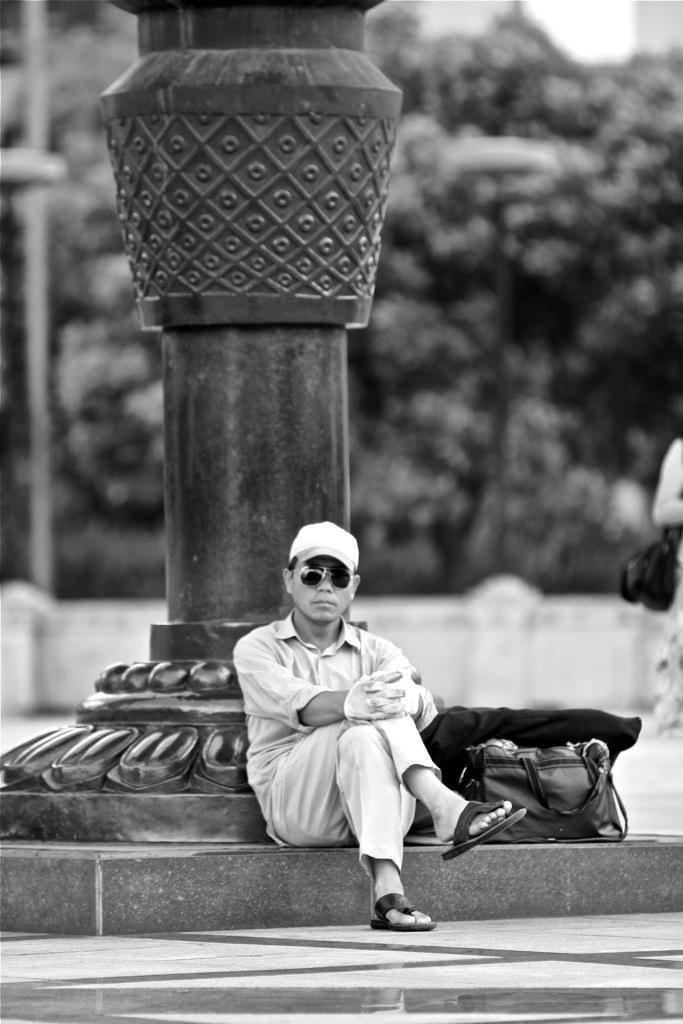Can you describe this image briefly? There is a person wearing sunglasses and a cap, sitting on a slab. Beside him, there is a pole. In the background, there is a person standing, there is a pole, there are trees and there is a wall. And the background is blurred. 